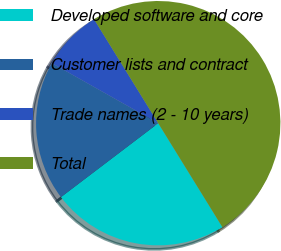Convert chart. <chart><loc_0><loc_0><loc_500><loc_500><pie_chart><fcel>Developed software and core<fcel>Customer lists and contract<fcel>Trade names (2 - 10 years)<fcel>Total<nl><fcel>23.46%<fcel>18.52%<fcel>8.02%<fcel>50.0%<nl></chart> 